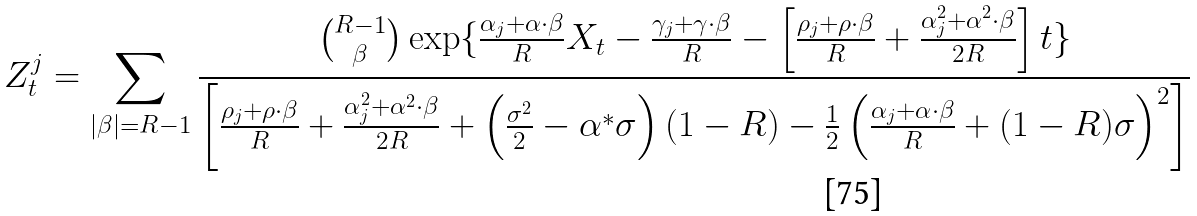Convert formula to latex. <formula><loc_0><loc_0><loc_500><loc_500>Z _ { t } ^ { j } = \sum _ { | \beta | = R - 1 } \frac { \binom { R - 1 } { \beta } \exp \{ \frac { \alpha _ { j } + \alpha \cdot \beta } { R } X _ { t } - \frac { \gamma _ { j } + \gamma \cdot \beta } { R } - \left [ \frac { \rho _ { j } + \rho \cdot \beta } { R } + \frac { \alpha _ { j } ^ { 2 } + \alpha ^ { 2 } \cdot \beta } { 2 R } \right ] t \} } { \left [ \frac { \rho _ { j } + \rho \cdot \beta } { R } + \frac { \alpha _ { j } ^ { 2 } + \alpha ^ { 2 } \cdot \beta } { 2 R } + \left ( \frac { \sigma ^ { 2 } } { 2 } - \alpha ^ { * } \sigma \right ) ( 1 - R ) - \frac { 1 } { 2 } \left ( \frac { \alpha _ { j } + \alpha \cdot \beta } { R } + ( 1 - R ) \sigma \right ) ^ { 2 } \right ] }</formula> 